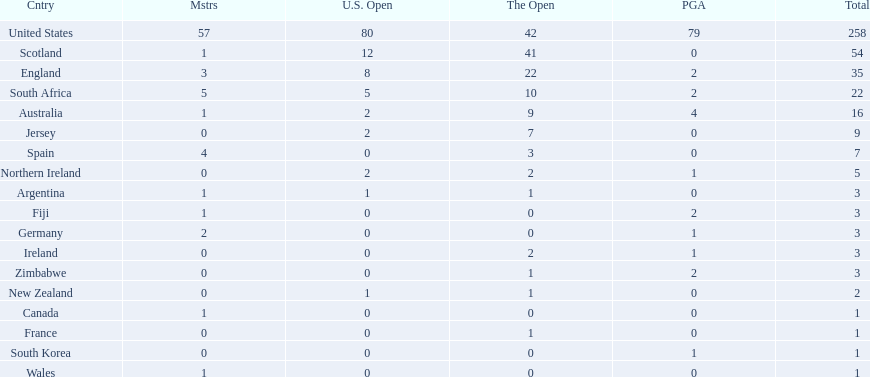Which of the countries listed are african? South Africa, Zimbabwe. Which of those has the least championship winning golfers? Zimbabwe. 